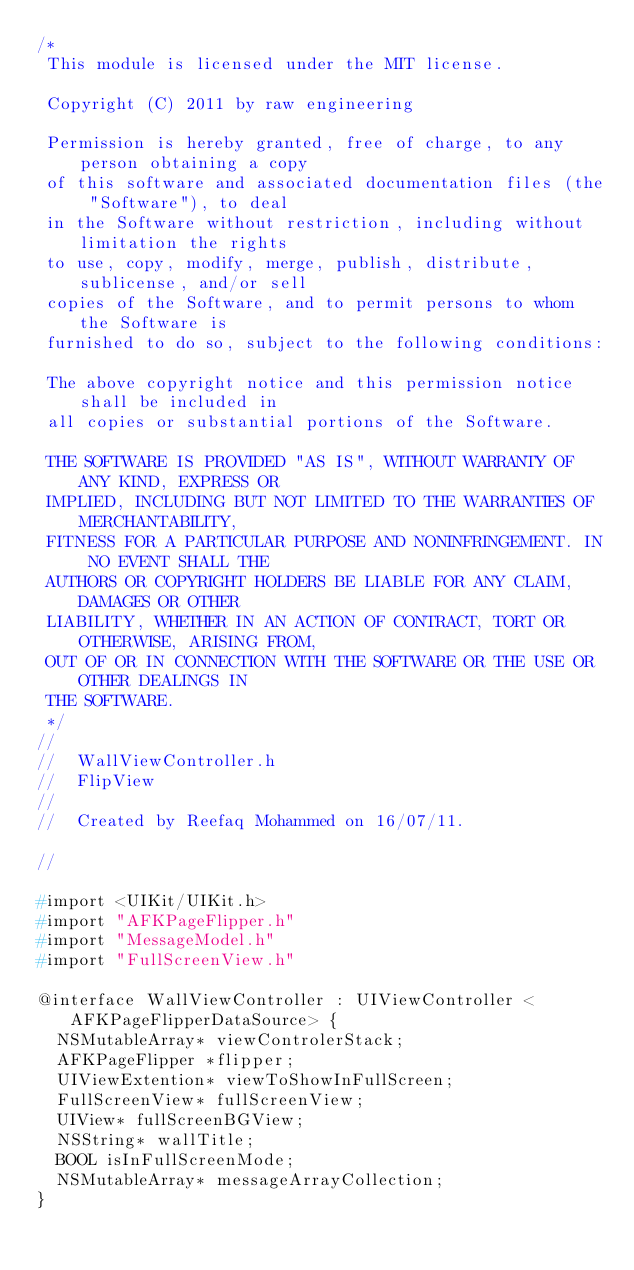Convert code to text. <code><loc_0><loc_0><loc_500><loc_500><_C_>/*
 This module is licensed under the MIT license.
 
 Copyright (C) 2011 by raw engineering
 
 Permission is hereby granted, free of charge, to any person obtaining a copy
 of this software and associated documentation files (the "Software"), to deal
 in the Software without restriction, including without limitation the rights
 to use, copy, modify, merge, publish, distribute, sublicense, and/or sell
 copies of the Software, and to permit persons to whom the Software is
 furnished to do so, subject to the following conditions:
 
 The above copyright notice and this permission notice shall be included in
 all copies or substantial portions of the Software.
 
 THE SOFTWARE IS PROVIDED "AS IS", WITHOUT WARRANTY OF ANY KIND, EXPRESS OR
 IMPLIED, INCLUDING BUT NOT LIMITED TO THE WARRANTIES OF MERCHANTABILITY,
 FITNESS FOR A PARTICULAR PURPOSE AND NONINFRINGEMENT. IN NO EVENT SHALL THE
 AUTHORS OR COPYRIGHT HOLDERS BE LIABLE FOR ANY CLAIM, DAMAGES OR OTHER
 LIABILITY, WHETHER IN AN ACTION OF CONTRACT, TORT OR OTHERWISE, ARISING FROM,
 OUT OF OR IN CONNECTION WITH THE SOFTWARE OR THE USE OR OTHER DEALINGS IN
 THE SOFTWARE.
 */
//
//  WallViewController.h
//  FlipView
//
//  Created by Reefaq Mohammed on 16/07/11.
 
//

#import <UIKit/UIKit.h>
#import "AFKPageFlipper.h"
#import "MessageModel.h"
#import "FullScreenView.h"

@interface WallViewController : UIViewController <AFKPageFlipperDataSource> {
	NSMutableArray* viewControlerStack;	
	AFKPageFlipper *flipper;
	UIViewExtention* viewToShowInFullScreen;
	FullScreenView* fullScreenView;
	UIView* fullScreenBGView;
	NSString* wallTitle;
	BOOL isInFullScreenMode;
	NSMutableArray* messageArrayCollection;
}
</code> 